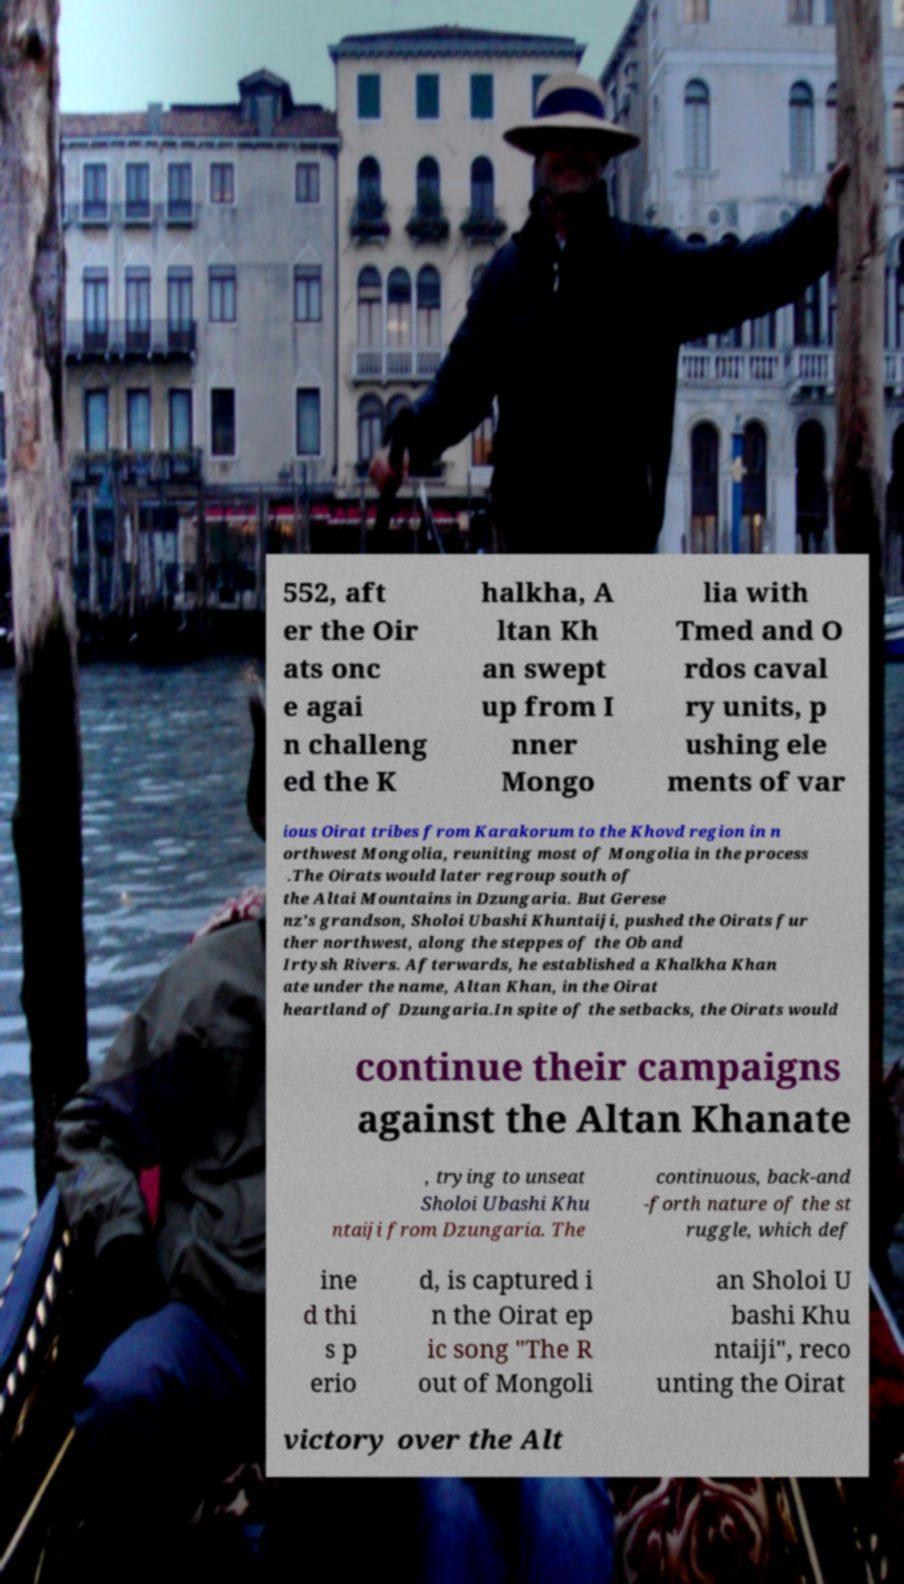What messages or text are displayed in this image? I need them in a readable, typed format. 552, aft er the Oir ats onc e agai n challeng ed the K halkha, A ltan Kh an swept up from I nner Mongo lia with Tmed and O rdos caval ry units, p ushing ele ments of var ious Oirat tribes from Karakorum to the Khovd region in n orthwest Mongolia, reuniting most of Mongolia in the process .The Oirats would later regroup south of the Altai Mountains in Dzungaria. But Gerese nz's grandson, Sholoi Ubashi Khuntaiji, pushed the Oirats fur ther northwest, along the steppes of the Ob and Irtysh Rivers. Afterwards, he established a Khalkha Khan ate under the name, Altan Khan, in the Oirat heartland of Dzungaria.In spite of the setbacks, the Oirats would continue their campaigns against the Altan Khanate , trying to unseat Sholoi Ubashi Khu ntaiji from Dzungaria. The continuous, back-and -forth nature of the st ruggle, which def ine d thi s p erio d, is captured i n the Oirat ep ic song "The R out of Mongoli an Sholoi U bashi Khu ntaiji", reco unting the Oirat victory over the Alt 